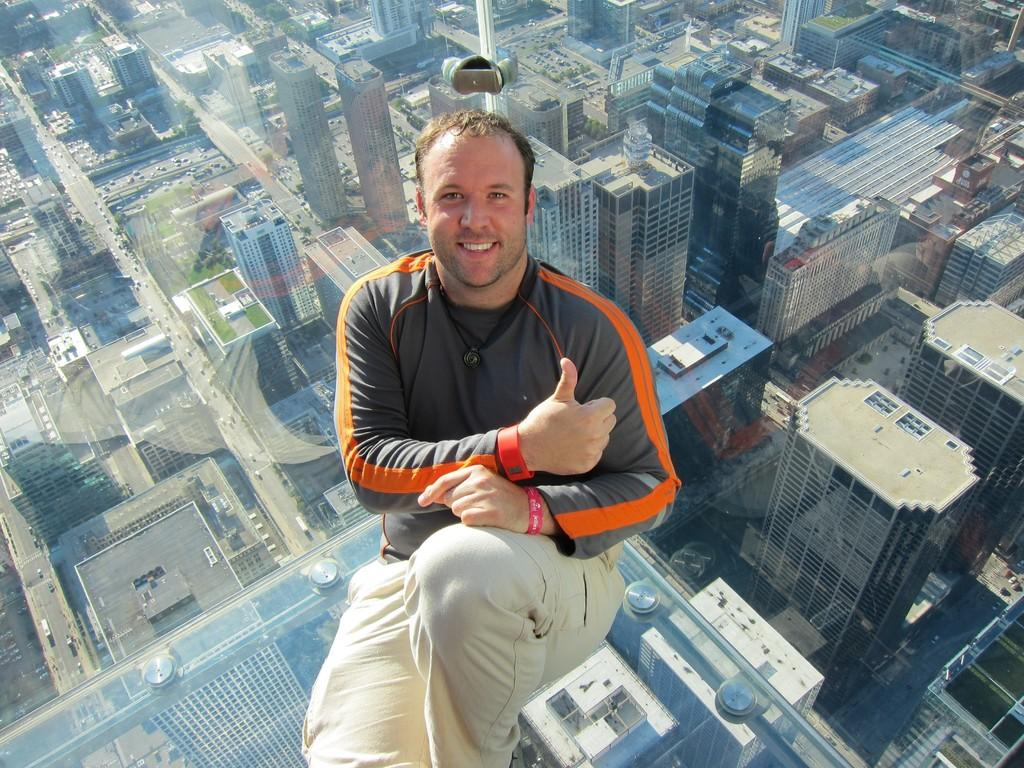What is the main subject of the image? There is a man in the image. What is the man's facial expression? The man is smiling. What can be seen in the background of the image? There are buildings in the background of the image. What type of clam is the man holding in the image? There is no clam present in the image; the man is not holding anything. 